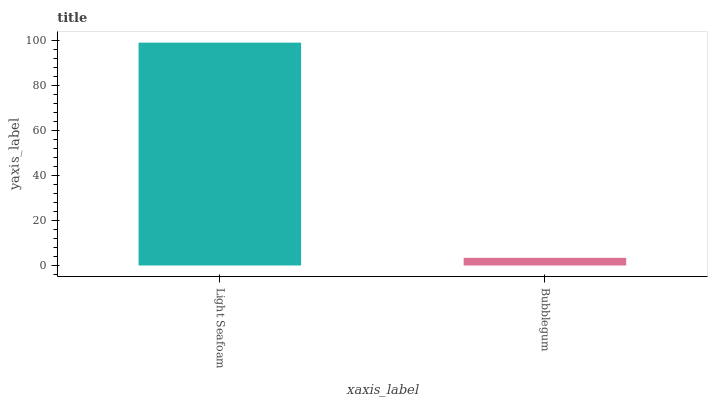Is Bubblegum the maximum?
Answer yes or no. No. Is Light Seafoam greater than Bubblegum?
Answer yes or no. Yes. Is Bubblegum less than Light Seafoam?
Answer yes or no. Yes. Is Bubblegum greater than Light Seafoam?
Answer yes or no. No. Is Light Seafoam less than Bubblegum?
Answer yes or no. No. Is Light Seafoam the high median?
Answer yes or no. Yes. Is Bubblegum the low median?
Answer yes or no. Yes. Is Bubblegum the high median?
Answer yes or no. No. Is Light Seafoam the low median?
Answer yes or no. No. 